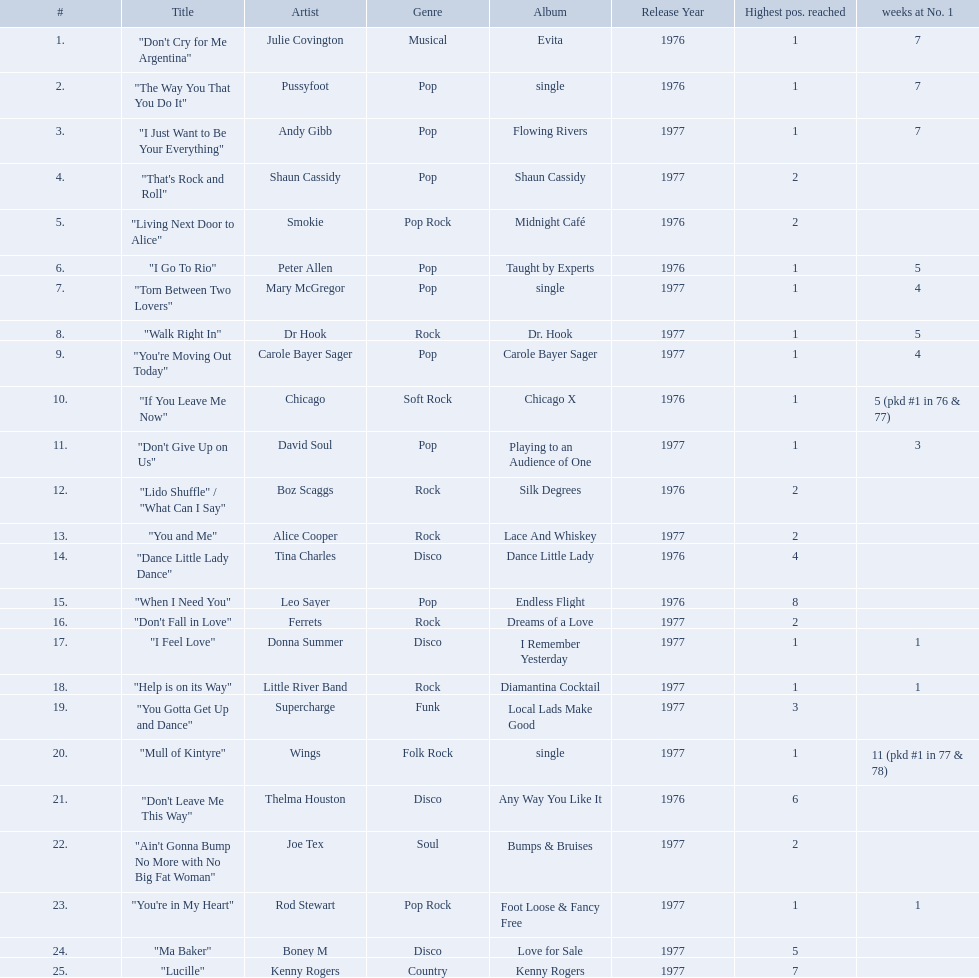Which artists were included in the top 25 singles for 1977 in australia? Julie Covington, Pussyfoot, Andy Gibb, Shaun Cassidy, Smokie, Peter Allen, Mary McGregor, Dr Hook, Carole Bayer Sager, Chicago, David Soul, Boz Scaggs, Alice Cooper, Tina Charles, Leo Sayer, Ferrets, Donna Summer, Little River Band, Supercharge, Wings, Thelma Houston, Joe Tex, Rod Stewart, Boney M, Kenny Rogers. And for how many weeks did they chart at number 1? 7, 7, 7, , , 5, 4, 5, 4, 5 (pkd #1 in 76 & 77), 3, , , , , , 1, 1, , 11 (pkd #1 in 77 & 78), , , 1, , . Which artist was in the number 1 spot for most time? Wings. 